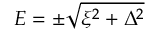<formula> <loc_0><loc_0><loc_500><loc_500>E = \pm \sqrt { \xi ^ { 2 } + \Delta ^ { 2 } }</formula> 